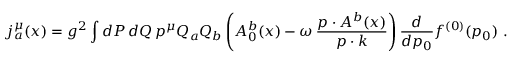<formula> <loc_0><loc_0><loc_500><loc_500>j _ { a } ^ { \mu } ( x ) = g ^ { 2 } \int d P \, d Q \, p ^ { \mu } Q _ { a } Q _ { b } \left ( A _ { 0 } ^ { b } ( x ) - \omega \, \frac { p \cdot A ^ { b } ( x ) } { p \cdot k } \right ) \frac { d } { d p _ { 0 } } f ^ { ( 0 ) } ( p _ { 0 } ) \ .</formula> 